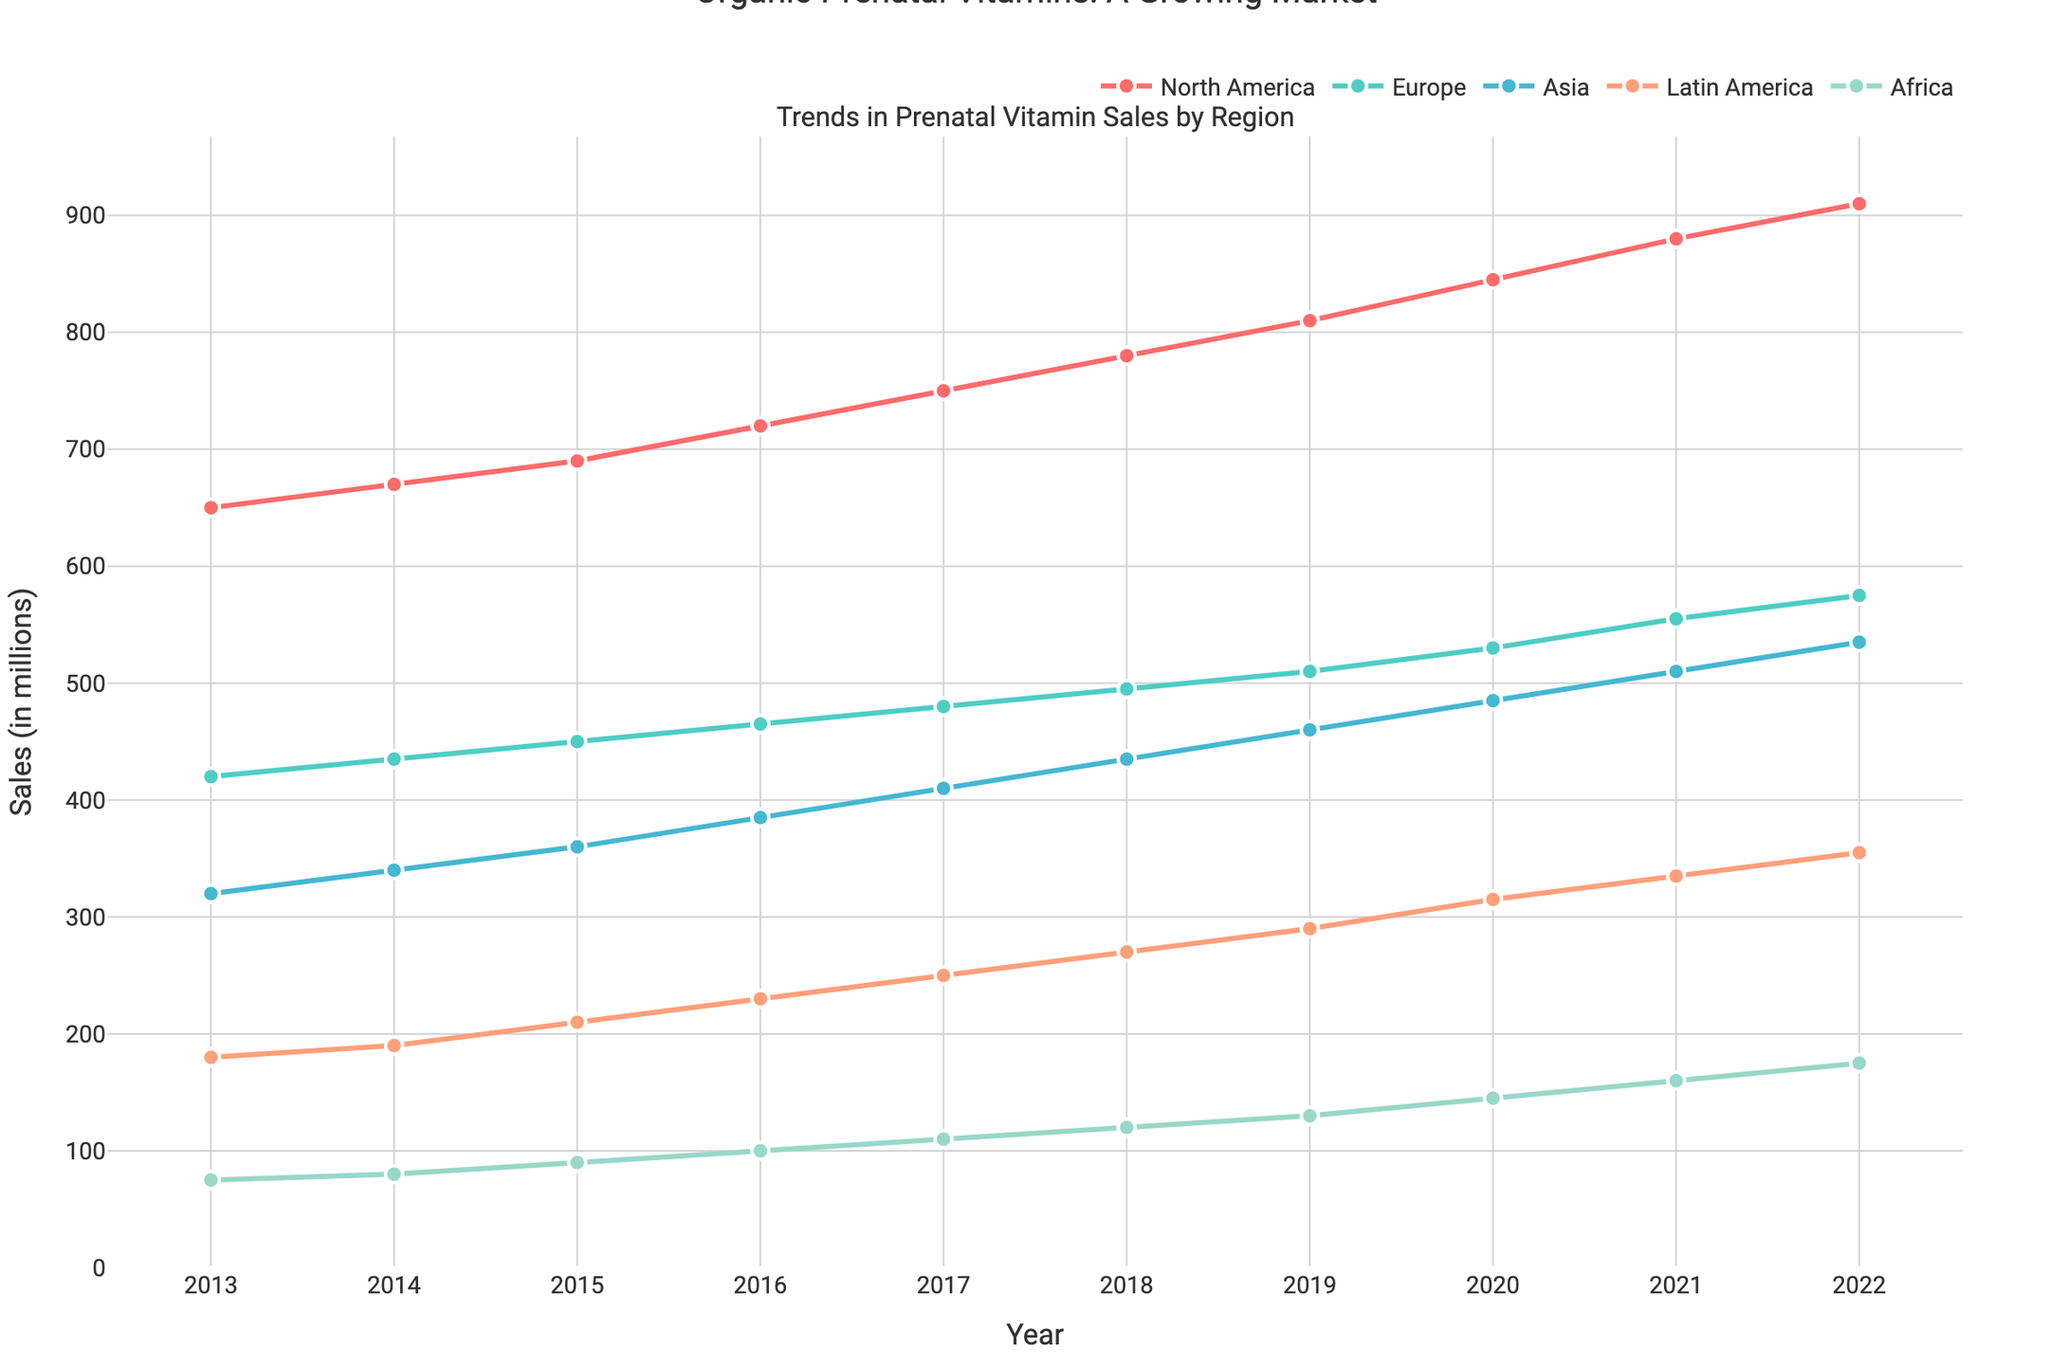What is the title of the figure? The title of the figure is found at the top of the image, providing context for the data displayed. It reads "Trends in Prenatal Vitamin Sales by Region".
Answer: Trends in Prenatal Vitamin Sales by Region Which region had the highest sales in 2022? By looking at the end of each line representing the year 2022, the North America line is at the highest point with a value of 910.
Answer: North America How did the sales in Asia change from 2013 to 2022? Find the data points for Asia in 2013 and 2022 and calculate the difference in sales values. In 2013, sales were 320 million, and in 2022, sales were 535 million. The change is 535 - 320 = 215 million.
Answer: Increased by 215 million Which region has the lowest sales growth over the decade? Analyze the gaps between the lines' starting points (2013) and endpoints (2022). Africa starts at 75 and ends at 175, showing a growth of 100 million, which is the smallest increase.
Answer: Africa What is the average sales growth per year for Europe from 2013 to 2022? Calculate the total growth from 2013 (420 million) to 2022 (575 million), which is 575 - 420 = 155 million. Divide this by the number of years (10) to get the average yearly growth: 155 / 10 = 15.5 million per year.
Answer: 15.5 million per year Which regions showed a consistent increase in sales every year? Examine the slope of each region's line. Consistent slope indicates a regular increase every year. All regions show a consistent upward trend without any dips.
Answer: All regions What was the difference in sales between North America and Europe in 2016? For 2016, find the data points for North America (720 million) and Europe (465 million). The difference is 720 - 465 = 255 million.
Answer: 255 million Which year saw the biggest increase in sales for Latin America? Compare the increase year-over-year for Latin America. The jump from 2019 (290 million) to 2020 (315 million) shows the largest increase: 315 - 290 = 25 million.
Answer: 2020 How did Africa's sales trend compare to that of Latin America over the decade? Africa started at 75 million in 2013 and ended at 175 million in 2022, while Latin America started at 180 million in 2013 and ended at 355 million in 2022. Both regions have an increasing trend, but Latin America saw a larger increase in magnitude.
Answer: Latin America had a larger increase What are the key insights from the plot regarding prenatal vitamin sales trends? Summarize the trends: all regions show increasing sales, with North America leading consistently, and Africa having the lowest sales. Europe and Asia also exhibit notable growth, while Latin America's significant rise is marked by a substantial increase in sales.
Answer: Increasing trend in all regions, North America leading, Africa lowest sales, strong growth in Europe, Asia, and Latin America 